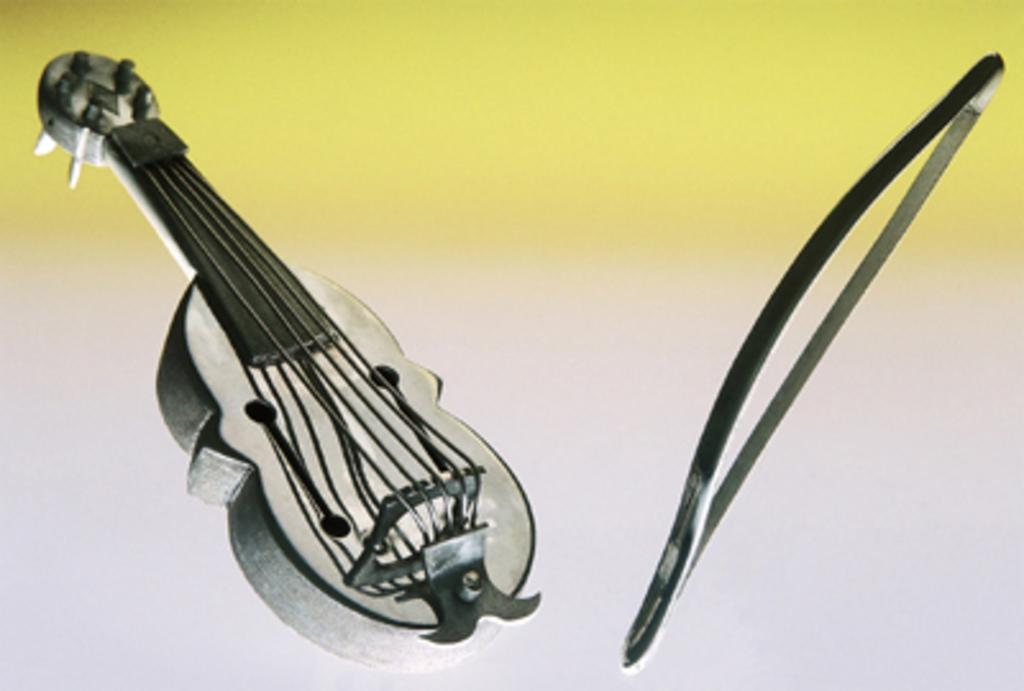What musical instrument is visible in the image? There is a violin in the image. What accessory is used with the violin in the image? The violin's bow is present in the image. How does the violin kick the ball in the image? The violin does not kick a ball in the image, as it is a musical instrument and not capable of such actions. 